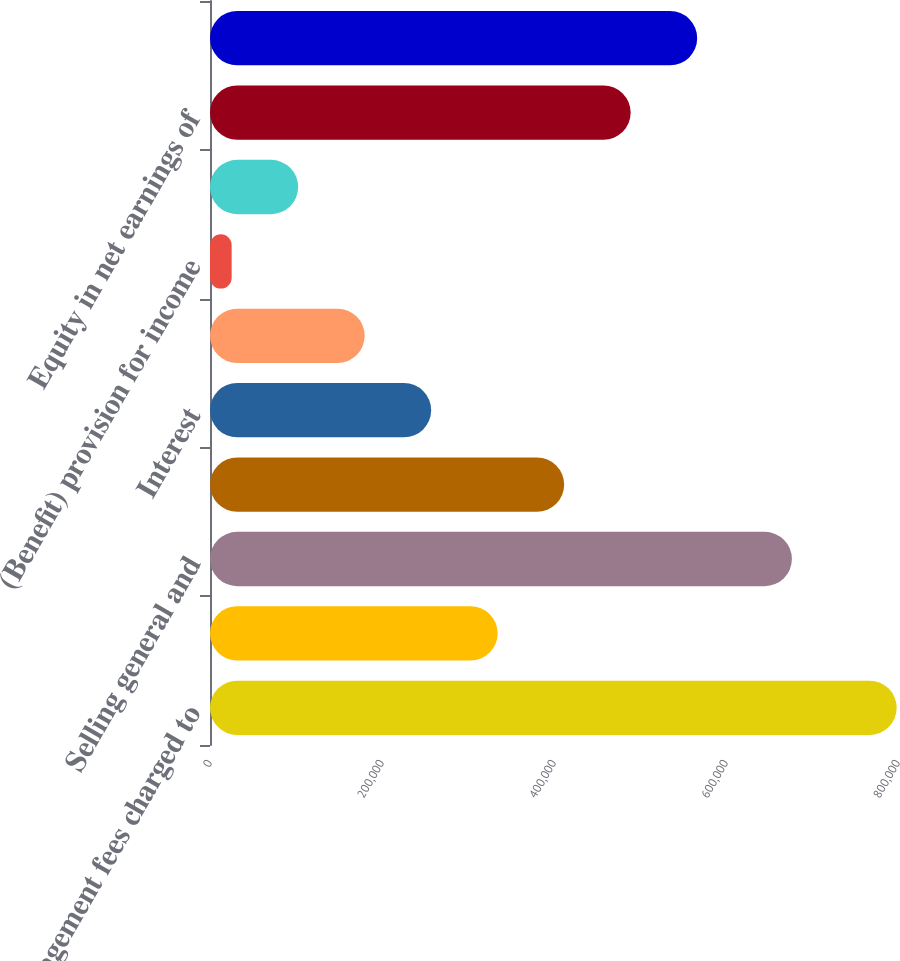<chart> <loc_0><loc_0><loc_500><loc_500><bar_chart><fcel>Management fees charged to<fcel>Investment and other income<fcel>Selling general and<fcel>Depreciation<fcel>Interest<fcel>(Loss) income before income<fcel>(Benefit) provision for income<fcel>(Loss) income before equity in<fcel>Equity in net earnings of<fcel>Net income<nl><fcel>798472<fcel>334497<fcel>676613<fcel>411826<fcel>257168<fcel>179839<fcel>25181<fcel>102510<fcel>489156<fcel>566485<nl></chart> 